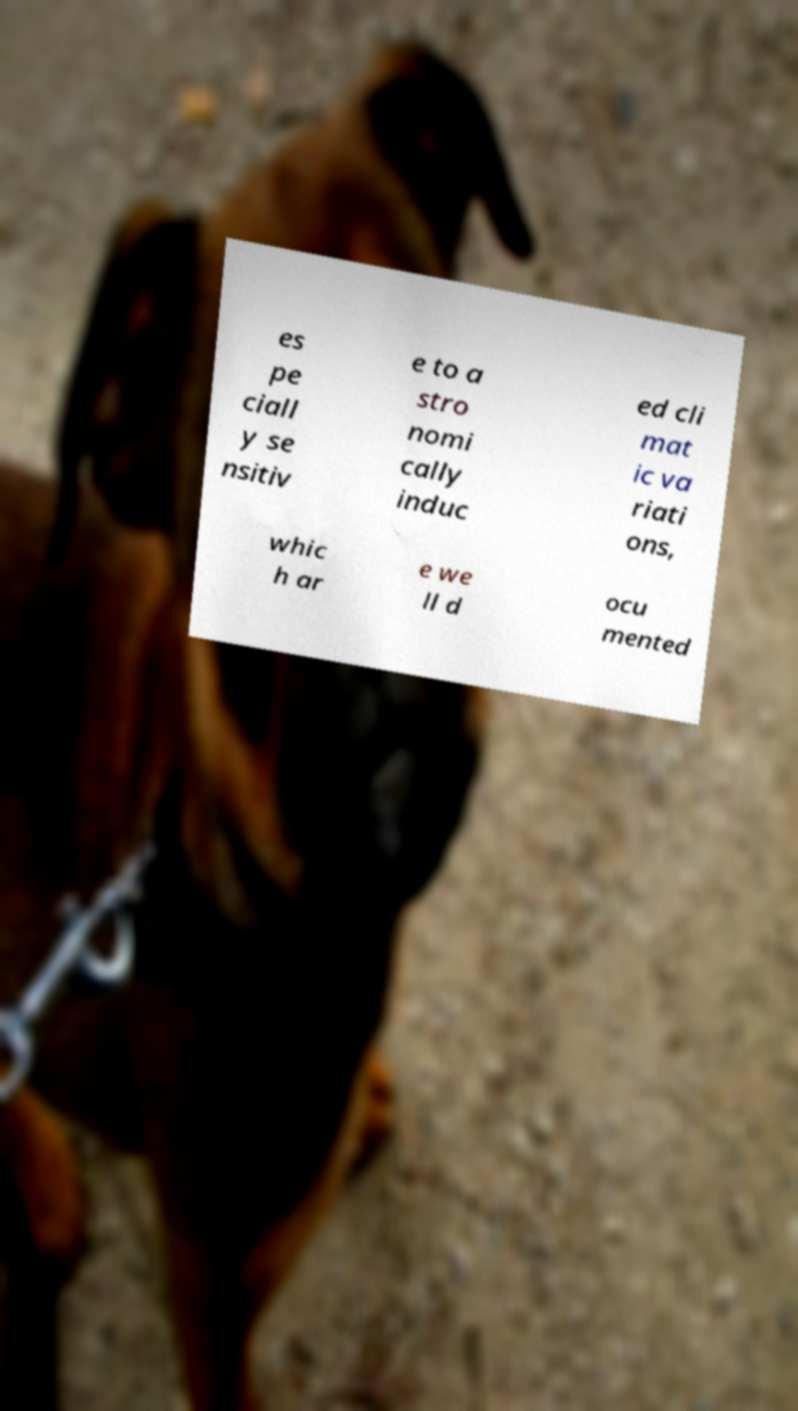Can you accurately transcribe the text from the provided image for me? es pe ciall y se nsitiv e to a stro nomi cally induc ed cli mat ic va riati ons, whic h ar e we ll d ocu mented 